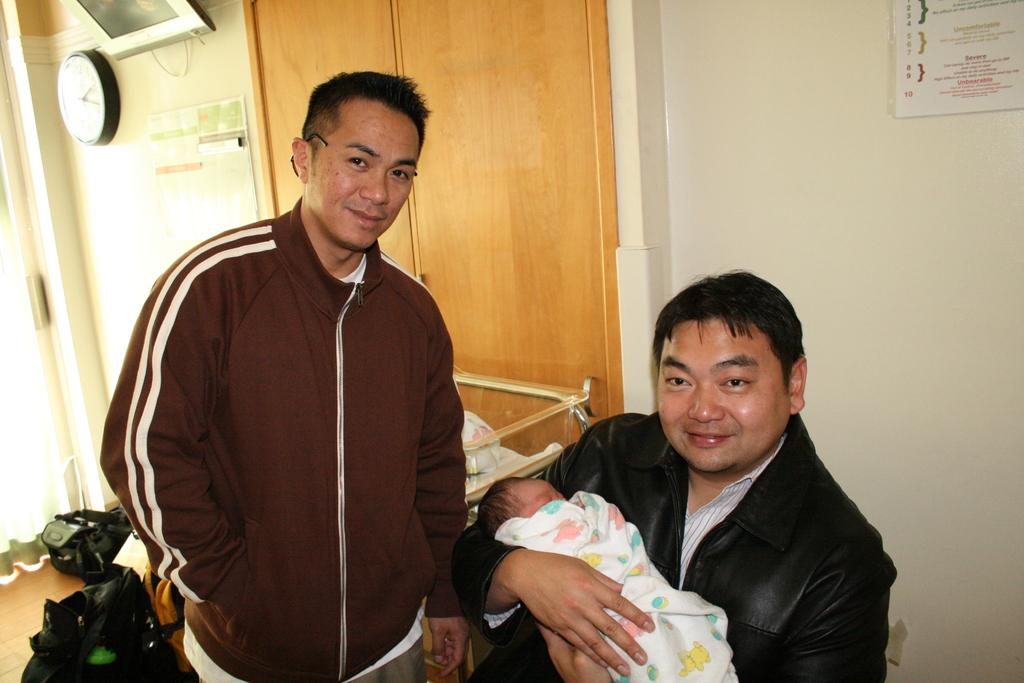How many people are in the image? There are two men in the image. What else can be seen in the image besides the men? There is a baby, a wall, a clock, a paper, and a photo frame in the image. Where is the clock located in the image? The clock is in the image. What might be used for writing or drawing in the image? The paper in the image might be used for writing or drawing. What type of ball can be seen bouncing in the image? There is no ball present in the image. What school do the men in the image attend? There is no information about the men attending school in the image. 